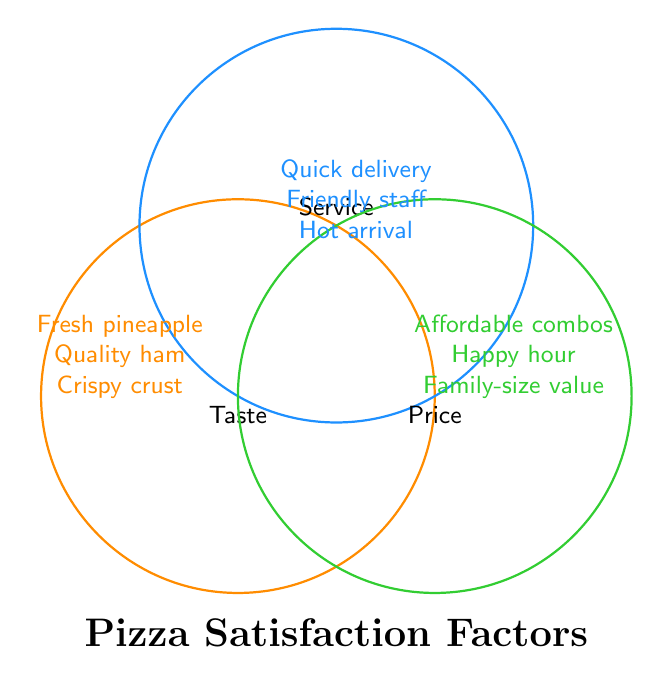What are the three categories shown in the Venn diagram? The Venn diagram shows three overlapping circles, each labeled differently: "Taste," "Service," and "Price." These represent the three categories.
Answer: Taste, Service, Price Which category includes "Pineapple freshness"? "Pineapple freshness" is listed within the circle labeled "Taste." Therefore, it belongs to the "Taste" category.
Answer: Taste Are "Order accuracy" and "Student discounts" linked to the same category? "Order accuracy" falls under "Service," and "Student discounts" fall under "Price." They are not linked to the same category.
Answer: No Which element appears in the "Service" category and involves hot delivery? Among the elements under the "Service" category, "Hot on arrival" specifically refers to hot delivery.
Answer: Hot on arrival What are the factors combined in the intersection of "Service" and "Price"? There is no specific intersection shown between "Service" and "Price." The overlapping areas do not list any combined factors explicitly, just individual ones.
Answer: None How many factors belong exclusively to the "Taste" category? The "Taste" circle lists the following factors: "Pineapple freshness," "Ham quality," "Crispy crust," "Cheese blend," and "Sauce tanginess," making it a total of five factors exclusive to "Taste."
Answer: Five Are there any common factors shared by "Taste," "Service," and "Price"? The innermost part of the Venn diagram where all three circles intersect is left blank, indicating that no common factors are shared among "Taste," "Service," and "Price."
Answer: No Is "Friendly staff" related to affordability or price discounts? "Friendly staff" appears under the "Service" category and has no connection to affordability or price discounts, which belong under "Price."
Answer: No 